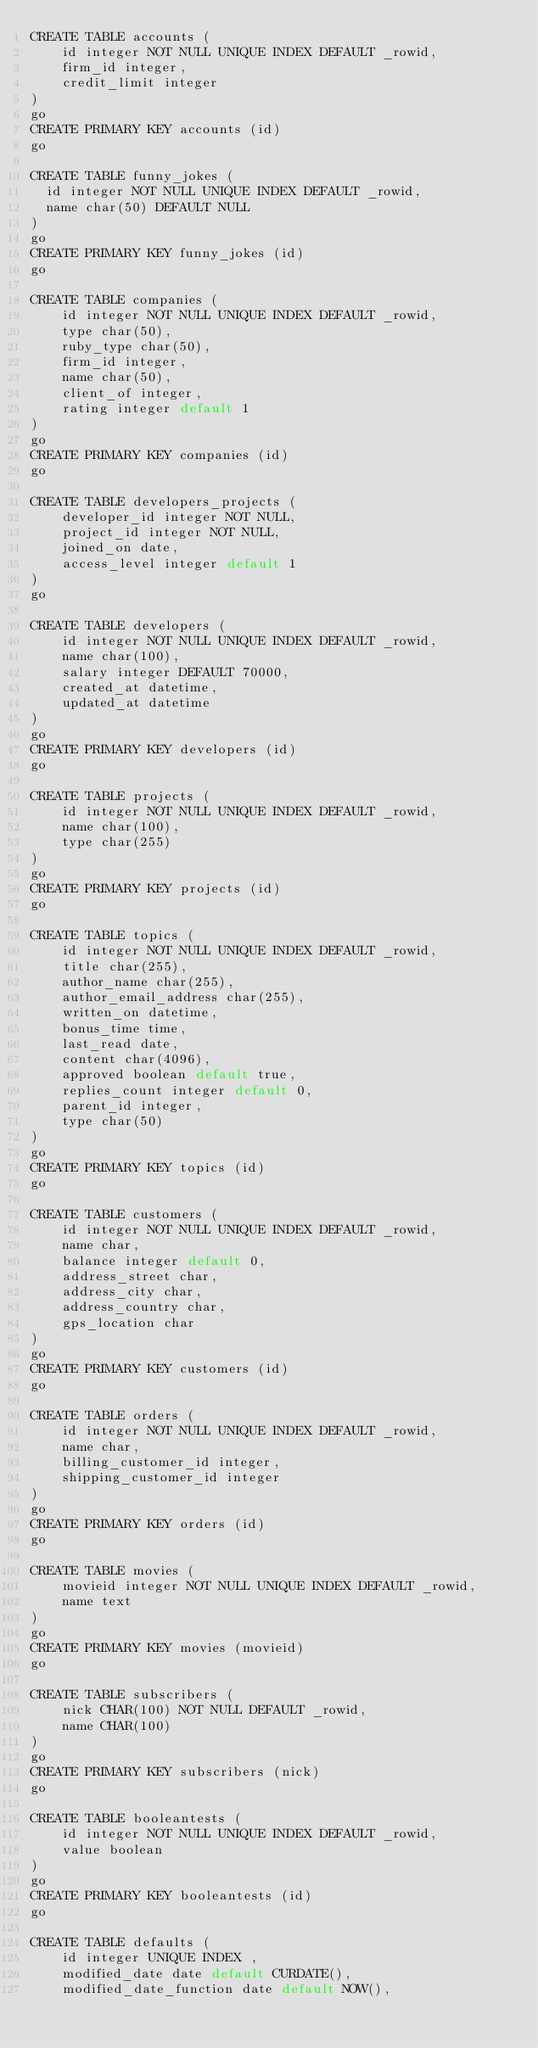<code> <loc_0><loc_0><loc_500><loc_500><_SQL_>CREATE TABLE accounts (
    id integer NOT NULL UNIQUE INDEX DEFAULT _rowid,
    firm_id integer,
    credit_limit integer
)
go
CREATE PRIMARY KEY accounts (id)
go

CREATE TABLE funny_jokes (
  id integer NOT NULL UNIQUE INDEX DEFAULT _rowid,
  name char(50) DEFAULT NULL
)
go
CREATE PRIMARY KEY funny_jokes (id)
go

CREATE TABLE companies (
    id integer NOT NULL UNIQUE INDEX DEFAULT _rowid,
    type char(50),
    ruby_type char(50),
    firm_id integer,
    name char(50),
    client_of integer,
    rating integer default 1
)
go
CREATE PRIMARY KEY companies (id)
go

CREATE TABLE developers_projects (
    developer_id integer NOT NULL,
    project_id integer NOT NULL,
    joined_on date,
    access_level integer default 1
)
go

CREATE TABLE developers (
    id integer NOT NULL UNIQUE INDEX DEFAULT _rowid,
    name char(100),
    salary integer DEFAULT 70000,
    created_at datetime,
    updated_at datetime
)
go
CREATE PRIMARY KEY developers (id)
go

CREATE TABLE projects (
    id integer NOT NULL UNIQUE INDEX DEFAULT _rowid,
    name char(100),
    type char(255)
)
go
CREATE PRIMARY KEY projects (id)
go

CREATE TABLE topics (
    id integer NOT NULL UNIQUE INDEX DEFAULT _rowid,
    title char(255),
    author_name char(255),
    author_email_address char(255),
    written_on datetime,
    bonus_time time,
    last_read date,
    content char(4096),
    approved boolean default true,
    replies_count integer default 0,
    parent_id integer,
    type char(50)
)
go
CREATE PRIMARY KEY topics (id)
go

CREATE TABLE customers (
    id integer NOT NULL UNIQUE INDEX DEFAULT _rowid,
    name char,
    balance integer default 0,
    address_street char,
    address_city char,
    address_country char,
    gps_location char
)
go
CREATE PRIMARY KEY customers (id)
go

CREATE TABLE orders (
    id integer NOT NULL UNIQUE INDEX DEFAULT _rowid,
    name char,
    billing_customer_id integer,
    shipping_customer_id integer
)
go
CREATE PRIMARY KEY orders (id)
go

CREATE TABLE movies (
    movieid integer NOT NULL UNIQUE INDEX DEFAULT _rowid,
    name text
)
go
CREATE PRIMARY KEY movies (movieid)
go

CREATE TABLE subscribers (
    nick CHAR(100) NOT NULL DEFAULT _rowid,
    name CHAR(100)
)
go
CREATE PRIMARY KEY subscribers (nick)
go

CREATE TABLE booleantests (
    id integer NOT NULL UNIQUE INDEX DEFAULT _rowid,
    value boolean
)
go
CREATE PRIMARY KEY booleantests (id)
go

CREATE TABLE defaults (
    id integer UNIQUE INDEX ,
    modified_date date default CURDATE(),
    modified_date_function date default NOW(),</code> 